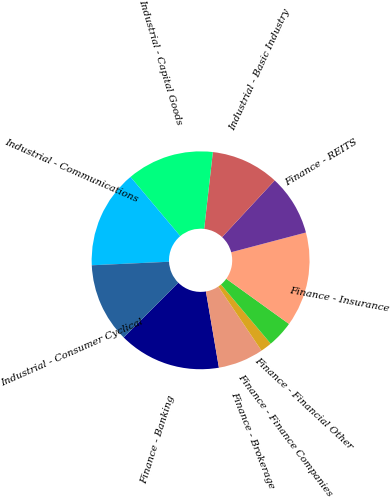<chart> <loc_0><loc_0><loc_500><loc_500><pie_chart><fcel>Finance - Banking<fcel>Finance - Brokerage<fcel>Finance - Finance Companies<fcel>Finance - Financial Other<fcel>Finance - Insurance<fcel>Finance - REITS<fcel>Industrial - Basic Industry<fcel>Industrial - Capital Goods<fcel>Industrial - Communications<fcel>Industrial - Consumer Cyclical<nl><fcel>15.16%<fcel>6.75%<fcel>1.69%<fcel>3.94%<fcel>14.04%<fcel>8.99%<fcel>10.11%<fcel>12.92%<fcel>14.6%<fcel>11.8%<nl></chart> 